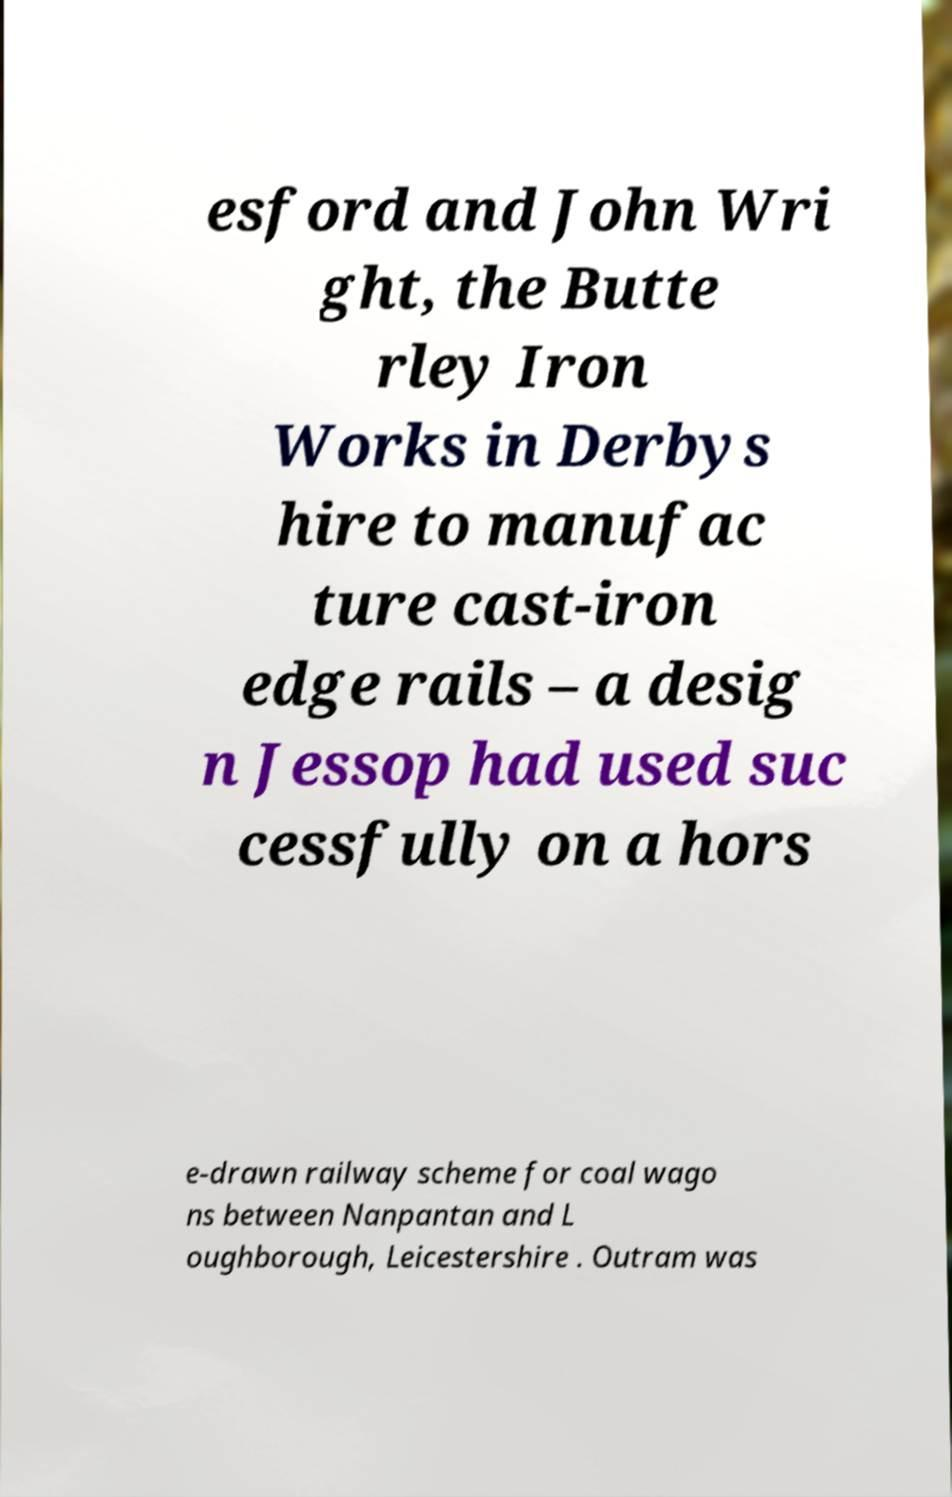For documentation purposes, I need the text within this image transcribed. Could you provide that? esford and John Wri ght, the Butte rley Iron Works in Derbys hire to manufac ture cast-iron edge rails – a desig n Jessop had used suc cessfully on a hors e-drawn railway scheme for coal wago ns between Nanpantan and L oughborough, Leicestershire . Outram was 